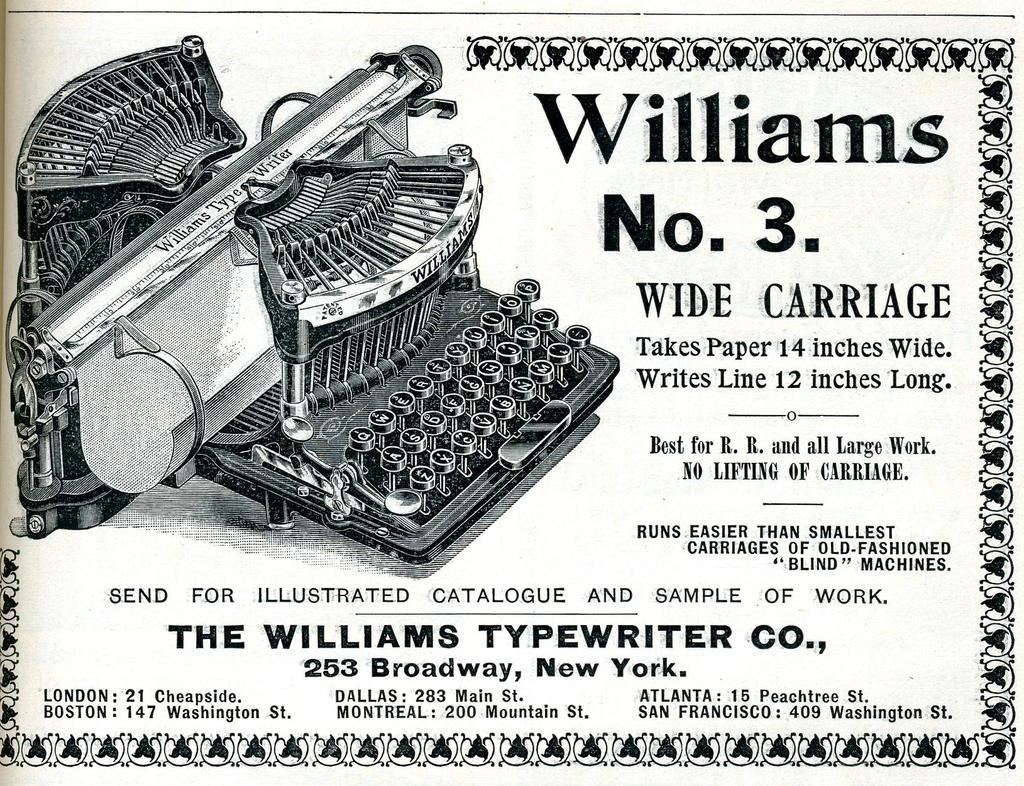<image>
Relay a brief, clear account of the picture shown. A vintage typewriter ad advertises a Williams No. 3 typewriter available in New York. 